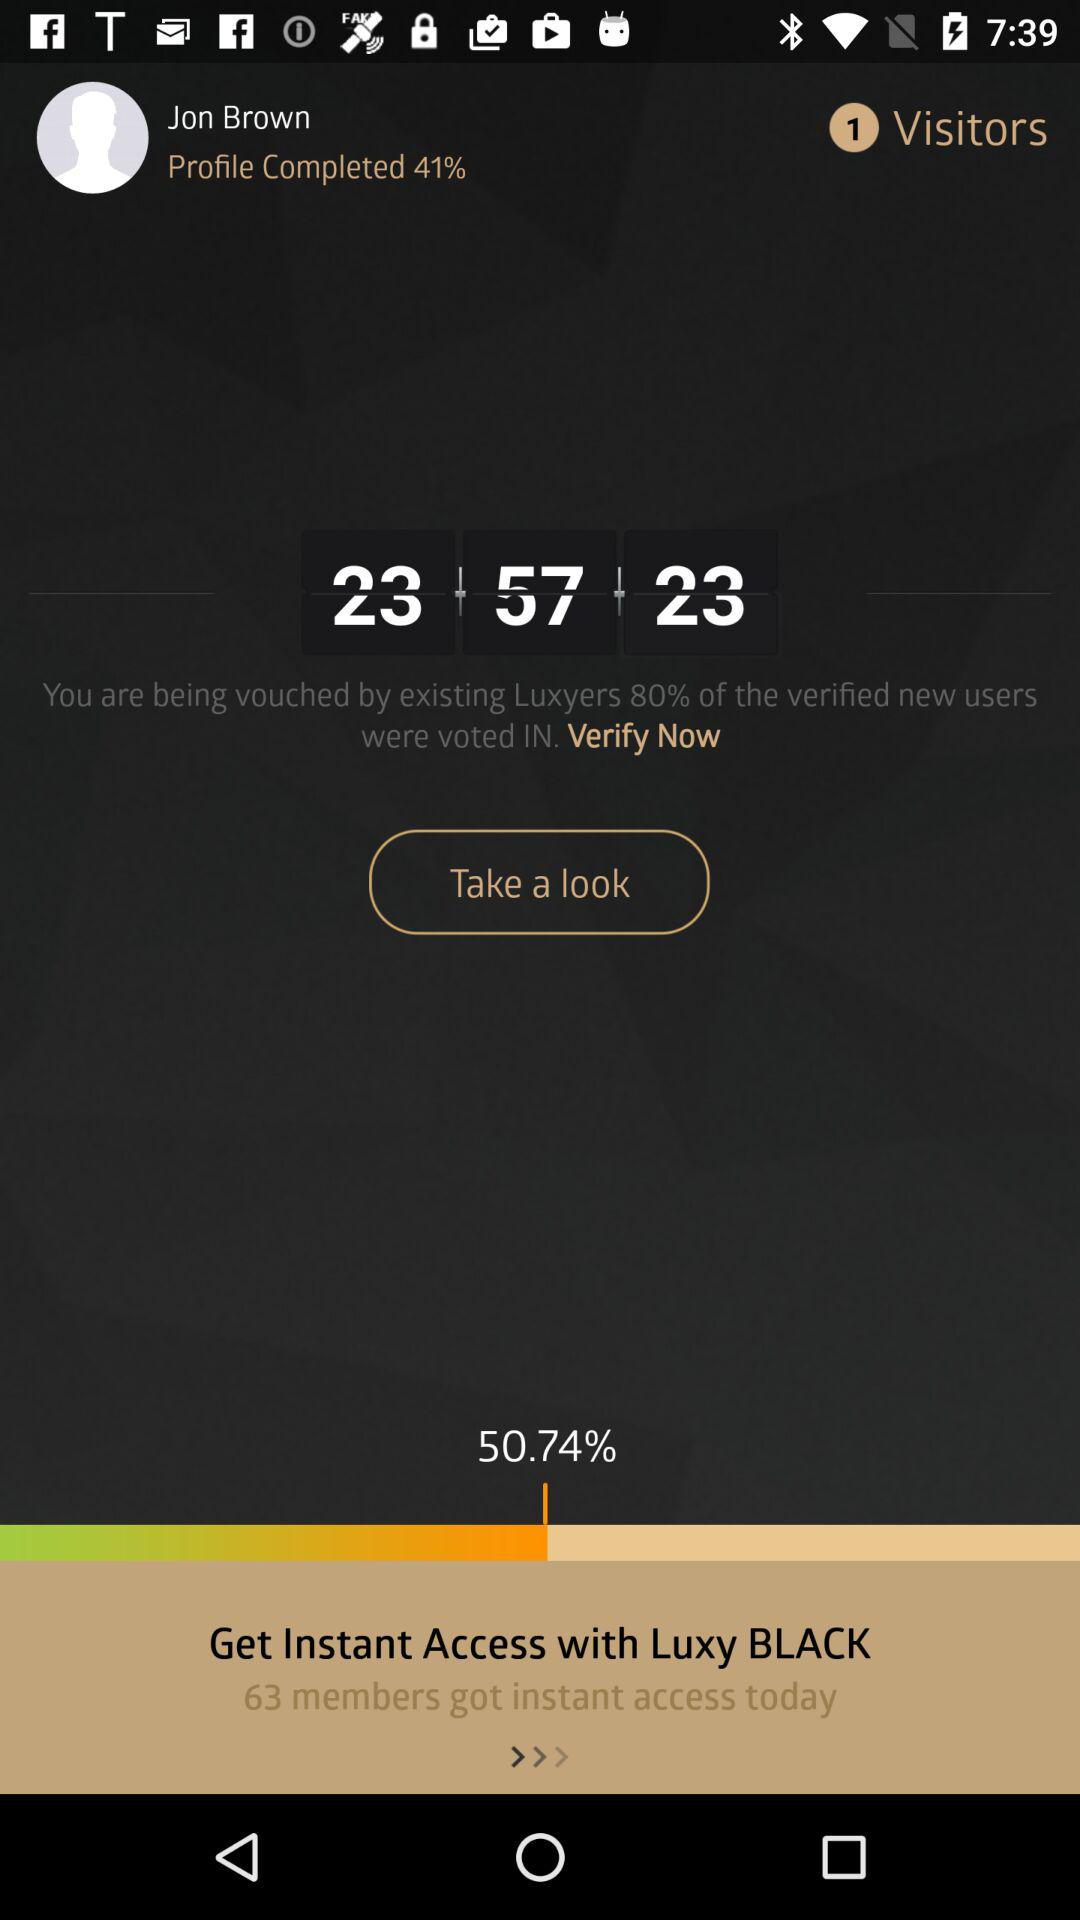What is the user's name? The user's name is Jon Brown. 